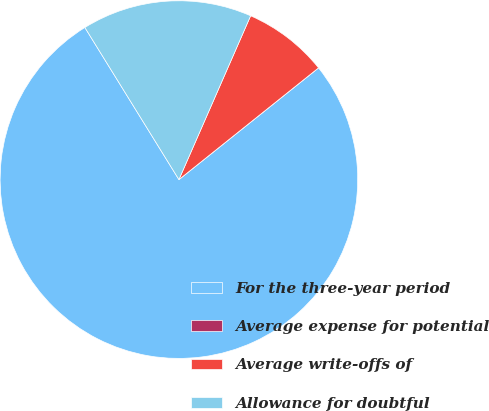Convert chart. <chart><loc_0><loc_0><loc_500><loc_500><pie_chart><fcel>For the three-year period<fcel>Average expense for potential<fcel>Average write-offs of<fcel>Allowance for doubtful<nl><fcel>76.92%<fcel>0.0%<fcel>7.69%<fcel>15.38%<nl></chart> 